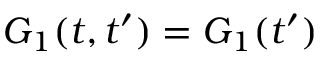<formula> <loc_0><loc_0><loc_500><loc_500>G _ { 1 } ( t , t ^ { \prime } ) = G _ { 1 } ( t ^ { \prime } )</formula> 